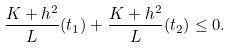Convert formula to latex. <formula><loc_0><loc_0><loc_500><loc_500>\frac { K + h ^ { 2 } } { L } ( t _ { 1 } ) + \frac { K + h ^ { 2 } } { L } ( t _ { 2 } ) \leq 0 .</formula> 